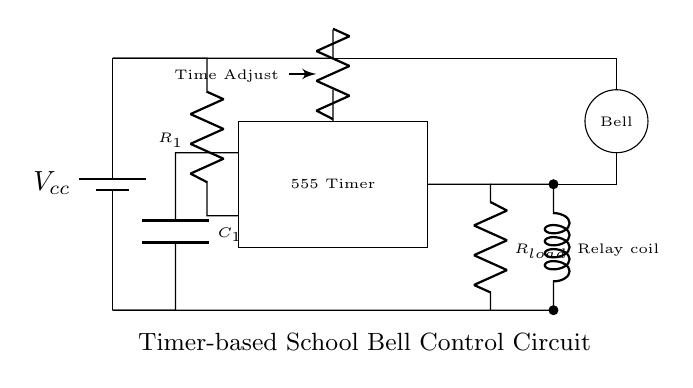What is the main component responsible for timing in this circuit? The main timing component in this circuit is the 555 Timer, which controls the timing intervals for the school bell.
Answer: 555 Timer What component is used to adjust the time duration? The component used to adjust the time duration is a potentiometer labeled as "Time Adjust." This device allows the user to change the resistance, thereby modifying the delay in the circuit.
Answer: Time Adjust What is the function of the relay in this circuit? The relay acts as a switch that allows a low-power signal from the timer to control a higher power load, such as the school bell. When activated by the timer, it closes the circuit for the bell to ring.
Answer: Switch How does the capacitor affect the timing mechanism? The capacitor charges and discharges during the timing cycles controlled by the 555 Timer, determining the period of the output signal and thus affecting how long the bell rings.
Answer: Charging and discharging What type of circuit is this? This is a timer-based circuit specifically designed for controlling a school bell schedule using a low-power 555 timer and relay components.
Answer: Timer-based circuit 